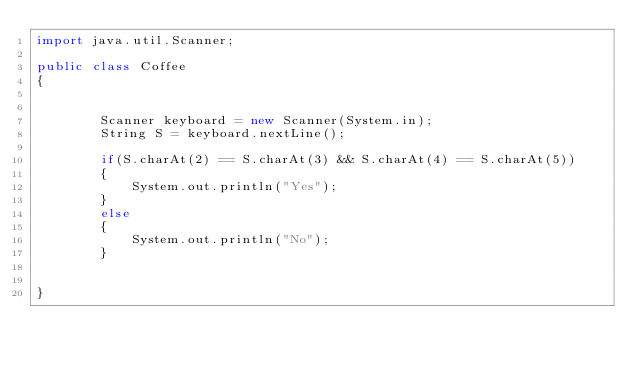Convert code to text. <code><loc_0><loc_0><loc_500><loc_500><_Java_>import java.util.Scanner;

public class Coffee
{
 
    
        Scanner keyboard = new Scanner(System.in);
        String S = keyboard.nextLine();
       
        if(S.charAt(2) == S.charAt(3) && S.charAt(4) == S.charAt(5))
        {
            System.out.println("Yes");
        }
        else
        {
            System.out.println("No");
        }
        
    
}</code> 